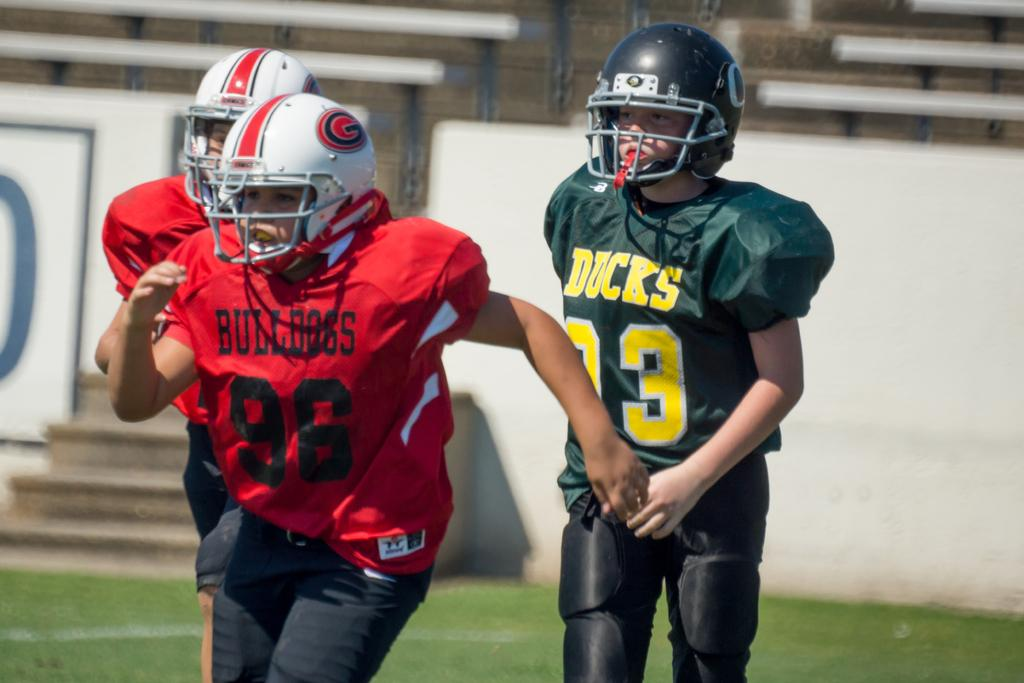How many people are in the image? There are three persons in the image. What are the persons wearing on their heads? The persons are wearing helmets. What type of clothing are the persons wearing? The persons are wearing sports dresses. What can be seen in the background of the image? There are benches, stairs, and a wall in the background of the image. Where is the map located in the image? There is no map present in the image. Can you tell me how many drawers are visible in the image? There are no drawers present in the image. 